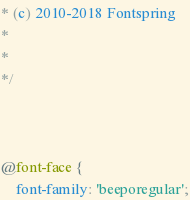<code> <loc_0><loc_0><loc_500><loc_500><_CSS_>* (c) 2010-2018 Fontspring
*
*
*/



@font-face {
    font-family: 'beeporegular';</code> 